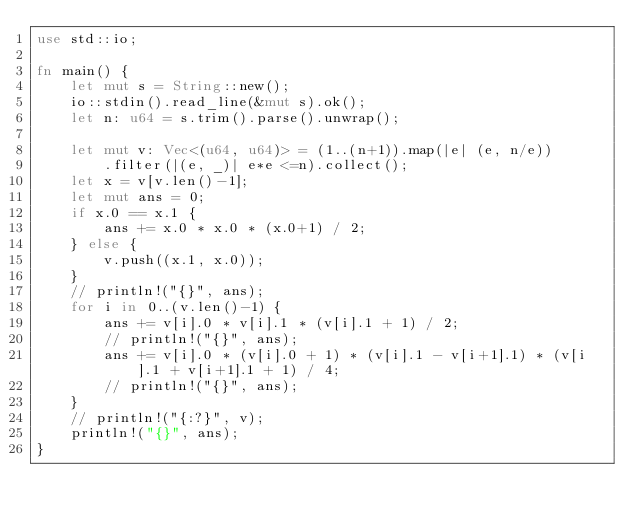<code> <loc_0><loc_0><loc_500><loc_500><_Rust_>use std::io;

fn main() {
    let mut s = String::new();
    io::stdin().read_line(&mut s).ok();
    let n: u64 = s.trim().parse().unwrap();

    let mut v: Vec<(u64, u64)> = (1..(n+1)).map(|e| (e, n/e))
        .filter(|(e, _)| e*e <=n).collect();
    let x = v[v.len()-1];
    let mut ans = 0;
    if x.0 == x.1 {
        ans += x.0 * x.0 * (x.0+1) / 2;
    } else {
        v.push((x.1, x.0));
    }
    // println!("{}", ans);
    for i in 0..(v.len()-1) {
        ans += v[i].0 * v[i].1 * (v[i].1 + 1) / 2;
        // println!("{}", ans);
        ans += v[i].0 * (v[i].0 + 1) * (v[i].1 - v[i+1].1) * (v[i].1 + v[i+1].1 + 1) / 4;
        // println!("{}", ans);
    }
    // println!("{:?}", v);
    println!("{}", ans);
}
</code> 